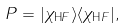Convert formula to latex. <formula><loc_0><loc_0><loc_500><loc_500>P = | \chi _ { \text  HF}\rangle\langle\chi_{\text  HF}| ,</formula> 